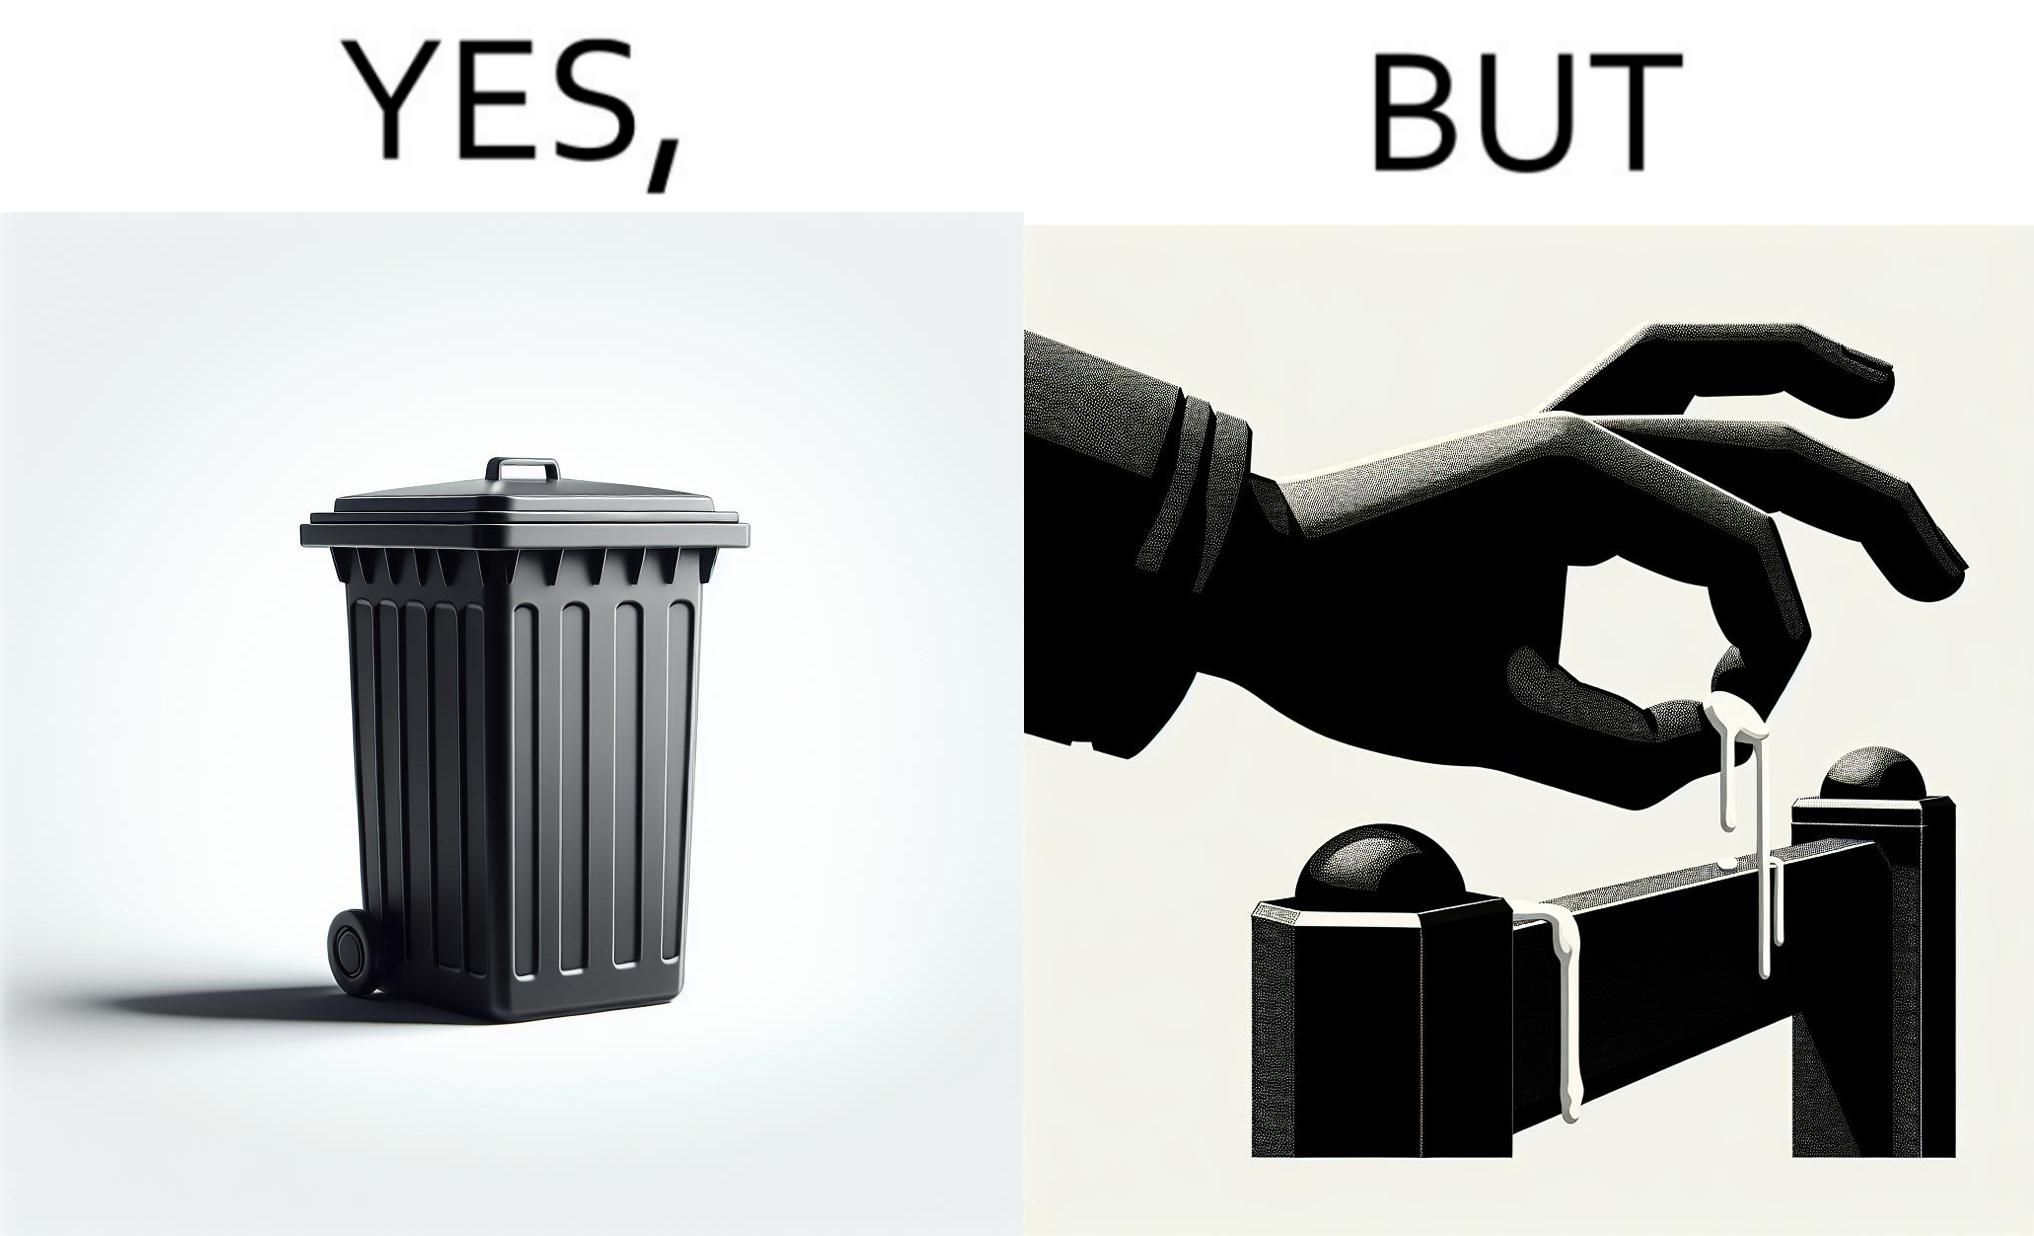What is shown in the left half versus the right half of this image? In the left part of the image: It is a garbage bin In the right part of the image: It is a human hand sticking chewing gum on public property 